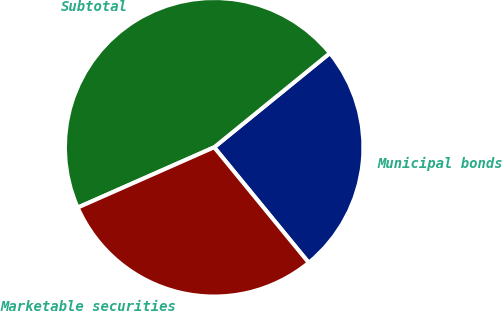Convert chart to OTSL. <chart><loc_0><loc_0><loc_500><loc_500><pie_chart><fcel>Municipal bonds<fcel>Subtotal<fcel>Marketable securities<nl><fcel>24.95%<fcel>45.75%<fcel>29.3%<nl></chart> 